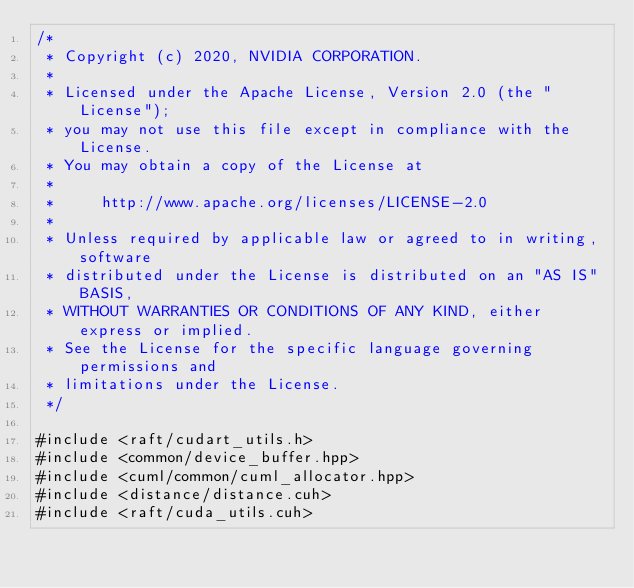<code> <loc_0><loc_0><loc_500><loc_500><_Cuda_>/*
 * Copyright (c) 2020, NVIDIA CORPORATION.
 *
 * Licensed under the Apache License, Version 2.0 (the "License");
 * you may not use this file except in compliance with the License.
 * You may obtain a copy of the License at
 *
 *     http://www.apache.org/licenses/LICENSE-2.0
 *
 * Unless required by applicable law or agreed to in writing, software
 * distributed under the License is distributed on an "AS IS" BASIS,
 * WITHOUT WARRANTIES OR CONDITIONS OF ANY KIND, either express or implied.
 * See the License for the specific language governing permissions and
 * limitations under the License.
 */

#include <raft/cudart_utils.h>
#include <common/device_buffer.hpp>
#include <cuml/common/cuml_allocator.hpp>
#include <distance/distance.cuh>
#include <raft/cuda_utils.cuh></code> 